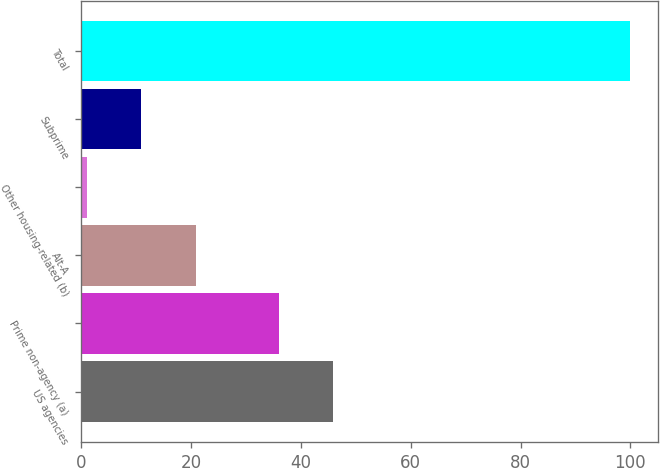Convert chart to OTSL. <chart><loc_0><loc_0><loc_500><loc_500><bar_chart><fcel>US agencies<fcel>Prime non-agency (a)<fcel>Alt-A<fcel>Other housing-related (b)<fcel>Subprime<fcel>Total<nl><fcel>45.9<fcel>36<fcel>20.8<fcel>1<fcel>10.9<fcel>100<nl></chart> 